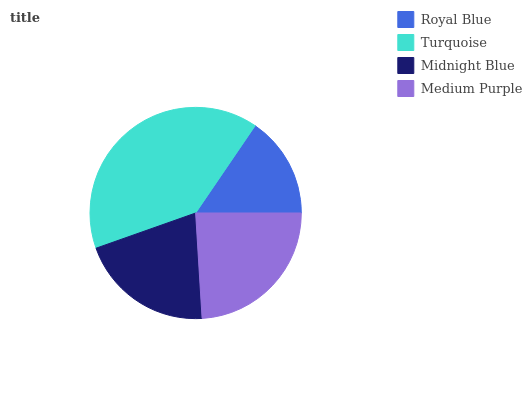Is Royal Blue the minimum?
Answer yes or no. Yes. Is Turquoise the maximum?
Answer yes or no. Yes. Is Midnight Blue the minimum?
Answer yes or no. No. Is Midnight Blue the maximum?
Answer yes or no. No. Is Turquoise greater than Midnight Blue?
Answer yes or no. Yes. Is Midnight Blue less than Turquoise?
Answer yes or no. Yes. Is Midnight Blue greater than Turquoise?
Answer yes or no. No. Is Turquoise less than Midnight Blue?
Answer yes or no. No. Is Medium Purple the high median?
Answer yes or no. Yes. Is Midnight Blue the low median?
Answer yes or no. Yes. Is Turquoise the high median?
Answer yes or no. No. Is Turquoise the low median?
Answer yes or no. No. 